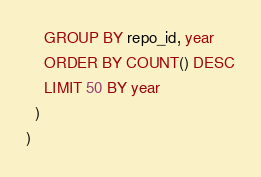Convert code to text. <code><loc_0><loc_0><loc_500><loc_500><_SQL_>    GROUP BY repo_id, year
    ORDER BY COUNT() DESC
    LIMIT 50 BY year
  )
)
</code> 